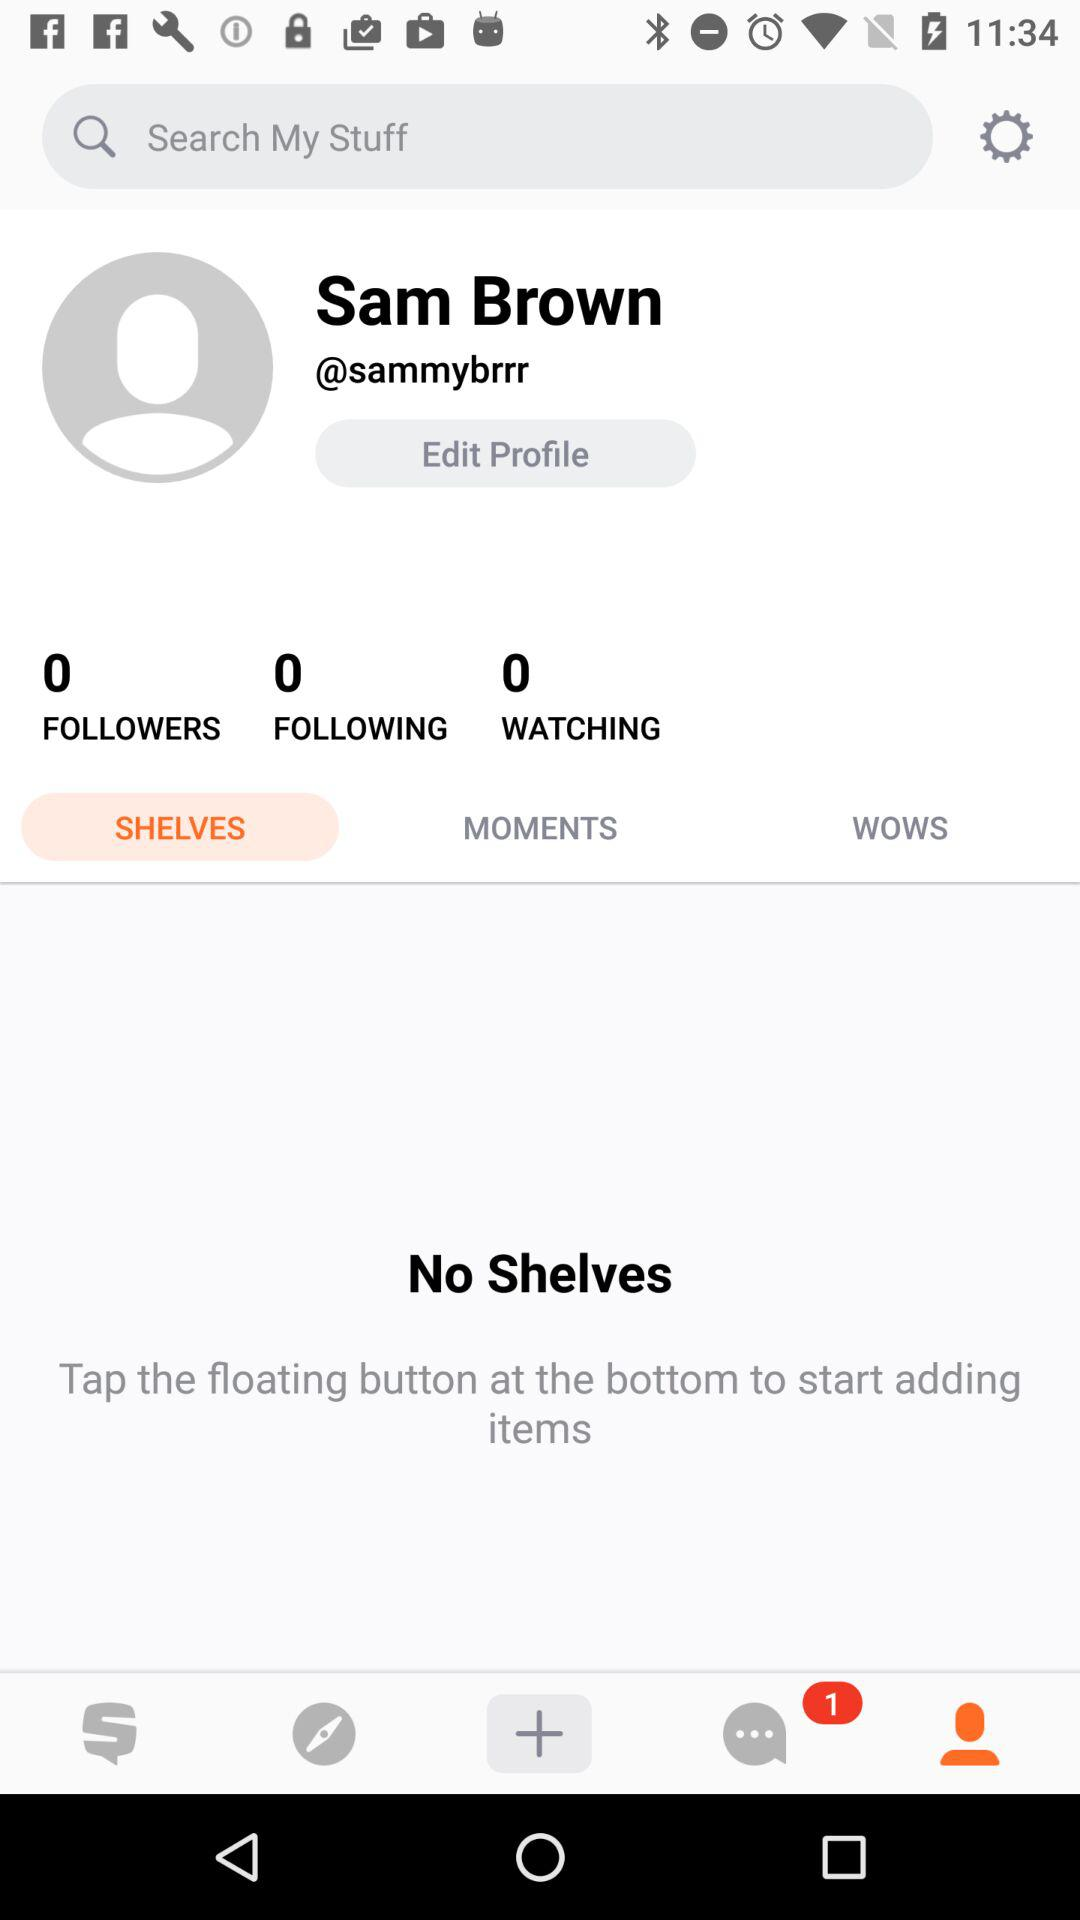How many people are "Following"? There are 0 people "Following". 